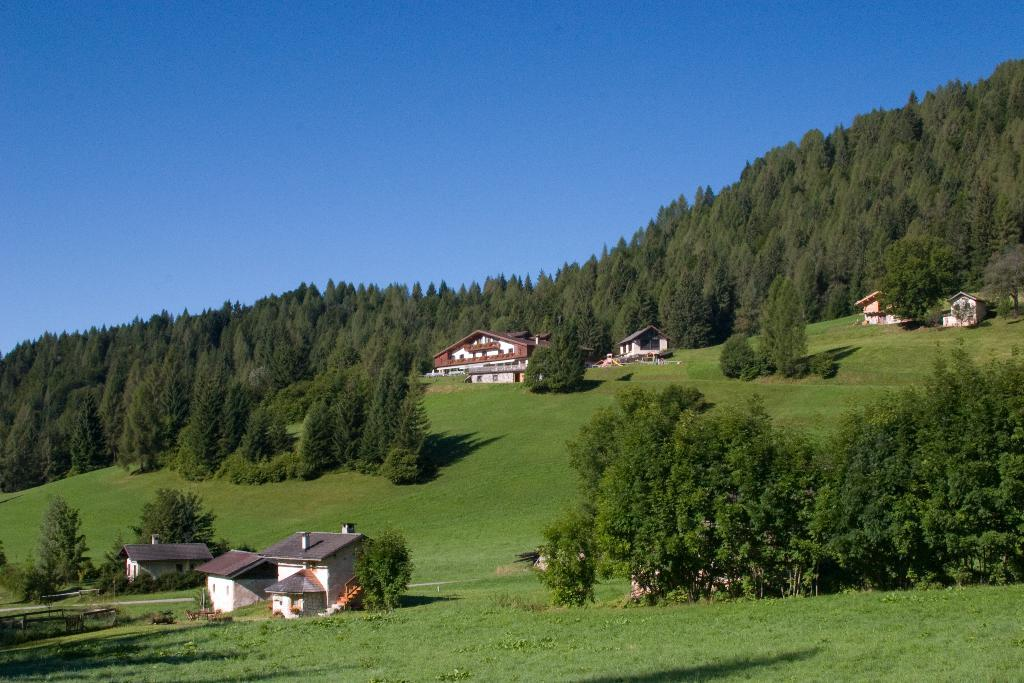What type of structures are present in the image? There is a group of buildings in the image. What type of vegetation can be seen in the image? There are trees in the image. What type of terrain is visible in the image? There is a grass field in the image. What is visible in the background of the image? The sky is visible in the background of the image. Can you see any patches of trouble in the grass field? There is no indication of trouble or patches in the grass field in the image. Are there any skateboarders visible in the image? There are no skateboarders present in the image. 